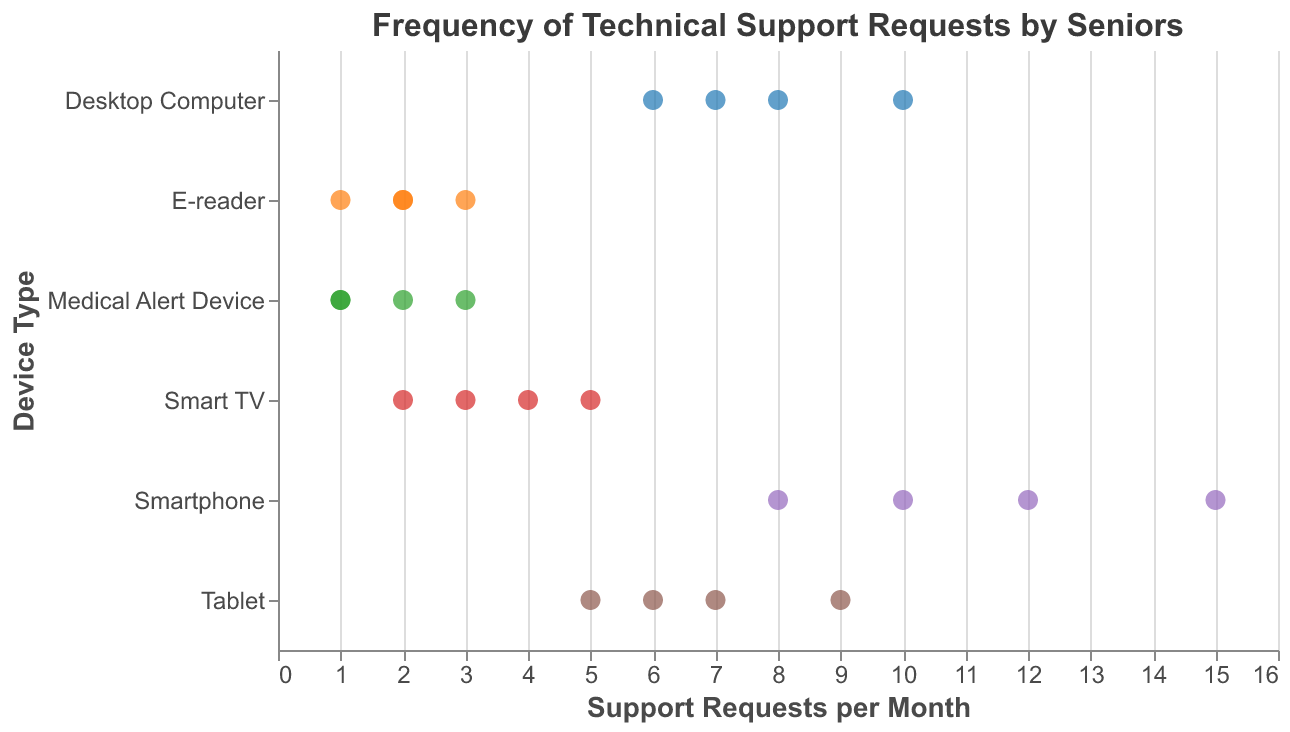What's the range of support requests for Smartphones? Look at the spread of data points along the x-axis for the Smartphone category. The minimum value is 8, and the maximum value is 15.
Answer: 12 to 15 Which device has the lowest frequency of support requests? Observe the data points along the x-axis for all device categories. The Medical Alert Device has data points as low as 1.
Answer: Medical Alert Device What is the average number of support requests for Tablets? Sum the data points (6, 9, 7, 5) for Tablets and divide by the number of data points: (6 + 9 + 7 + 5) / 4 = 27 / 4 = 6.75.
Answer: 6.75 How many data points are there for Smart TVs? Count the number of data points or markers in the Smart TV category. There are four data points.
Answer: 4 Which device type has the highest average number of support requests? Calculate the average for each device type and compare. Smartphones: (12+8+15+10)/4 = 11.25, Tablets: (6+9+7+5)/4 = 6.75, Smart TV: (3+5+2+4)/4 = 3.5, E-reader: (2+1+3+2)/4 = 2, Desktop Computer: (7+10+6+8)/4 = 7.75, Medical Alert Device: (1+2+1+3)/4 = 1.75. The Smartphone has the highest average.
Answer: Smartphone Are there any outliers in the Desktop Computer support request data? Look for data points significantly different from others within the Desktop Computer category, but all data points (7, 10, 6, 8) are relatively close.
Answer: No Which device consistently requires the least technical support? Look at the consistency and the range of the lowest data points. E-readers have consistently low support requests (1 to 3).
Answer: E-reader Compare the variability in support requests of Tablets and Desktop Computers. Which one has more variability? Look at the spread of data points. Tablet data points range from 5 to 9 (range = 4), and Desktop Computer range from 6 to 10 (range = 4). They have the same variability in terms of range.
Answer: Equal What is the maximum number of support requests for a Desktop Computer? Look at the highest data point in the Desktop Computer category. The maximum is 10.
Answer: 10 Between Smartphones and Smart TVs, which device receives more frequent support requests on average? Calculate the average support requests: Smartphones (12+8+15+10)/4 = 11.25, Smart TVs (3+5+2+4)/4 = 3.5.
Answer: Smartphones 